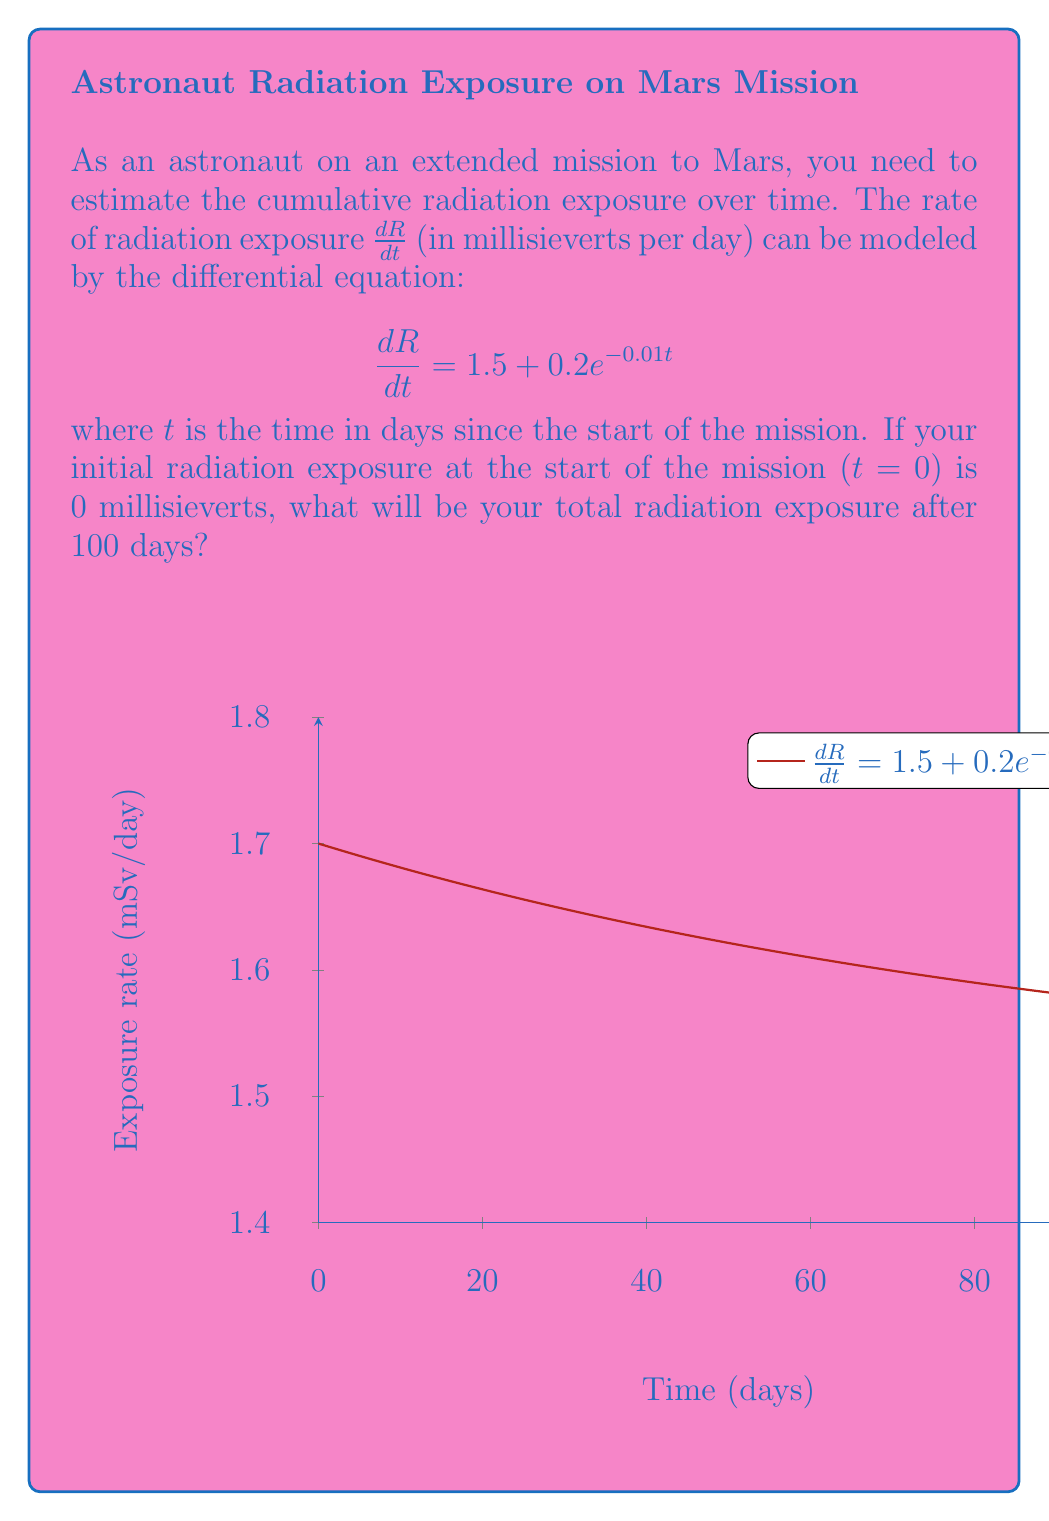Show me your answer to this math problem. To solve this problem, we need to integrate the given differential equation:

1) The differential equation is:
   $$\frac{dR}{dt} = 1.5 + 0.2e^{-0.01t}$$

2) To find the total radiation exposure, we need to integrate both sides:
   $$\int dR = \int (1.5 + 0.2e^{-0.01t}) dt$$

3) Integrating the right side:
   $$R = 1.5t - 20e^{-0.01t} + C$$

4) To find the constant of integration $C$, we use the initial condition $R(0) = 0$:
   $$0 = 1.5(0) - 20e^{-0.01(0)} + C$$
   $$0 = -20 + C$$
   $$C = 20$$

5) Therefore, the general solution is:
   $$R(t) = 1.5t - 20e^{-0.01t} + 20$$

6) To find the radiation exposure after 100 days, we substitute $t = 100$:
   $$R(100) = 1.5(100) - 20e^{-0.01(100)} + 20$$
   $$R(100) = 150 - 20e^{-1} + 20$$
   $$R(100) = 150 - 7.36 + 20 = 162.64$$

Thus, the total radiation exposure after 100 days is approximately 162.64 millisieverts.
Answer: 162.64 millisieverts 